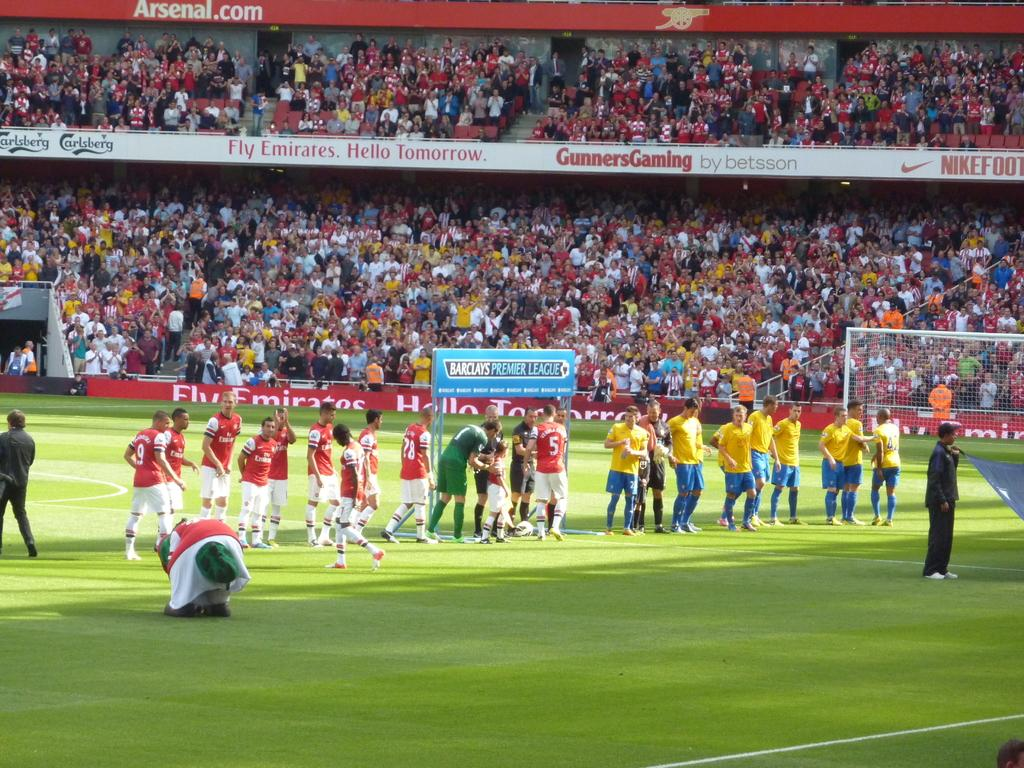<image>
Summarize the visual content of the image. Two soccer teams are preparing to play in the Barclays Premier League 